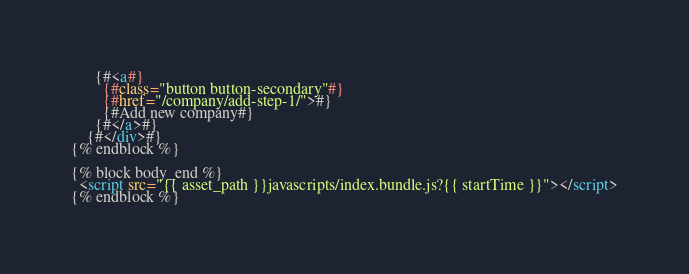Convert code to text. <code><loc_0><loc_0><loc_500><loc_500><_HTML_>      {#<a#}
        {#class="button button-secondary"#}
        {#href="/company/add-step-1/">#}
        {#Add new company#}
      {#</a>#}
    {#</div>#}
{% endblock %}

{% block body_end %}
  <script src="{{ asset_path }}javascripts/index.bundle.js?{{ startTime }}"></script>
{% endblock %}

</code> 